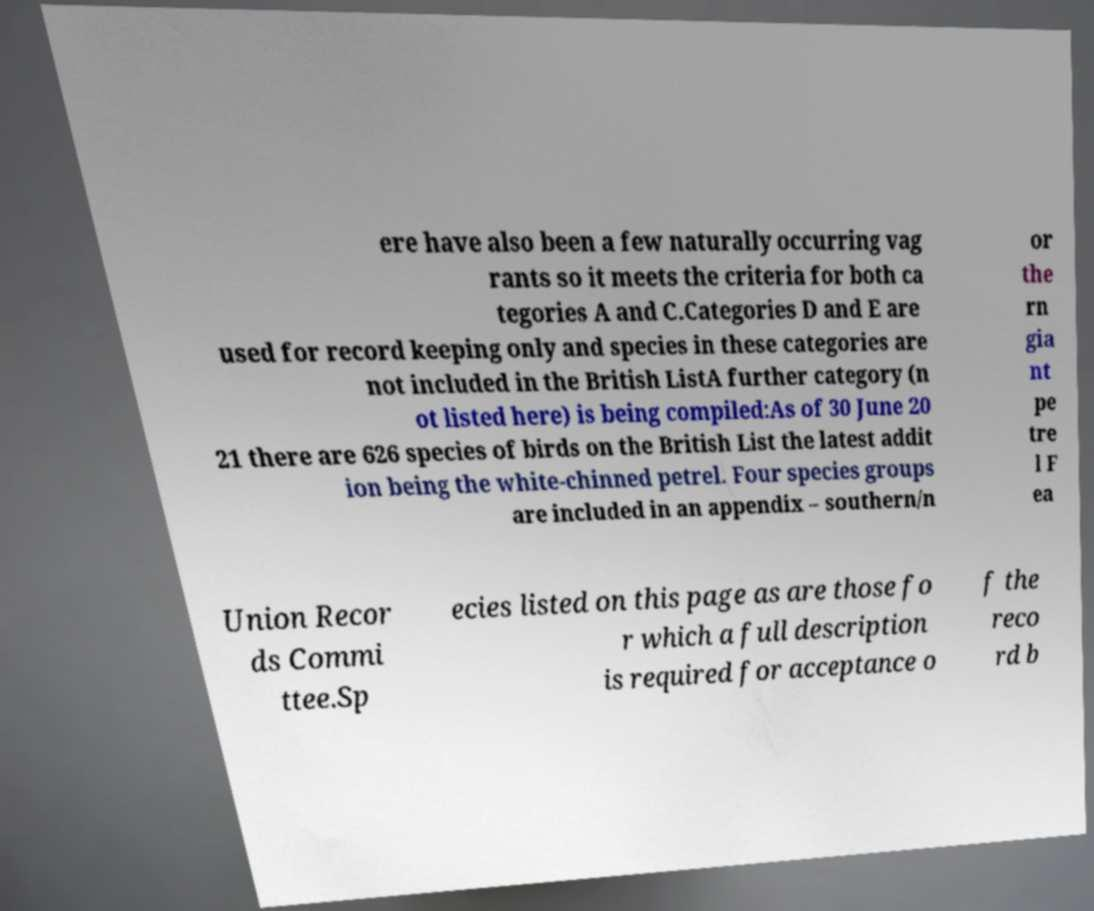Could you assist in decoding the text presented in this image and type it out clearly? ere have also been a few naturally occurring vag rants so it meets the criteria for both ca tegories A and C.Categories D and E are used for record keeping only and species in these categories are not included in the British ListA further category (n ot listed here) is being compiled:As of 30 June 20 21 there are 626 species of birds on the British List the latest addit ion being the white-chinned petrel. Four species groups are included in an appendix – southern/n or the rn gia nt pe tre l F ea Union Recor ds Commi ttee.Sp ecies listed on this page as are those fo r which a full description is required for acceptance o f the reco rd b 